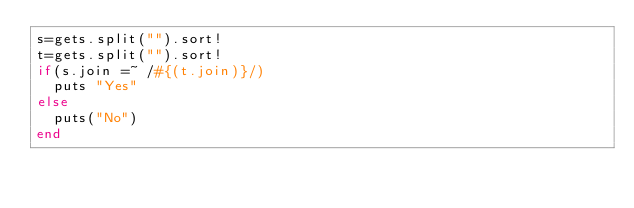Convert code to text. <code><loc_0><loc_0><loc_500><loc_500><_Ruby_>s=gets.split("").sort!
t=gets.split("").sort!
if(s.join =~ /#{(t.join)}/)
	puts "Yes"
else
	puts("No")
end</code> 